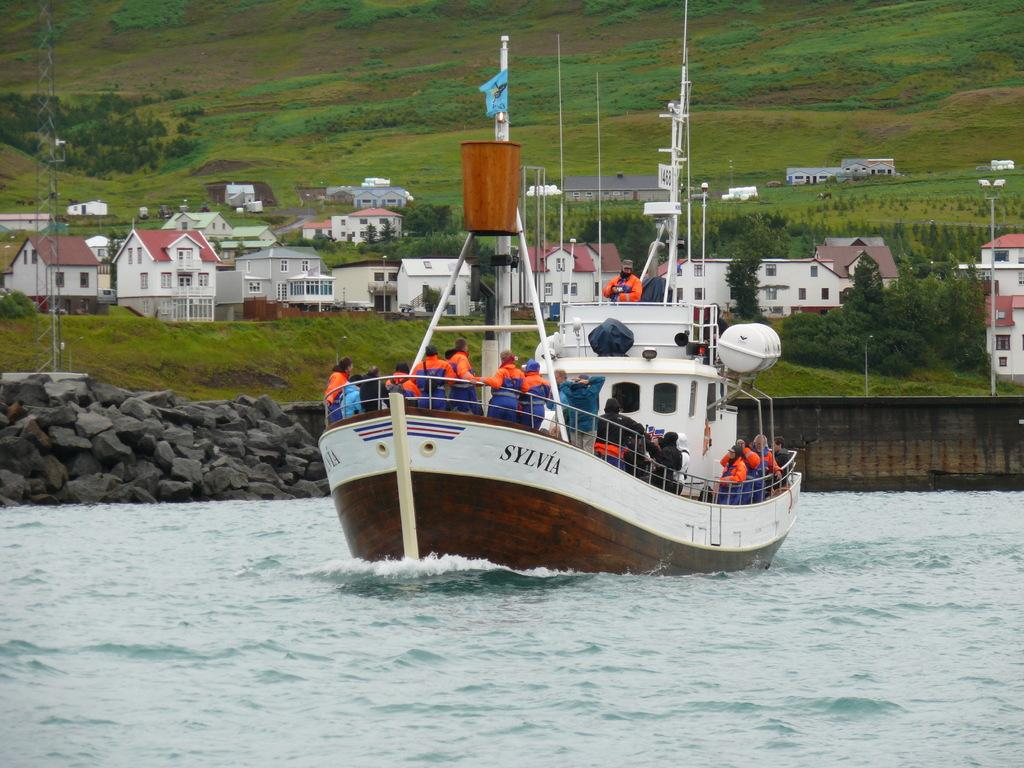How many people are in the image? There is a group of people in the image. Where are the people located in the image? The people are on a boat in the image. What is the boat on in the image? The boat is on the water in the image. What can be seen in the background of the image? There are rocks, trees, and houses in the background of the image. What type of produce is being harvested by the people in the image? There is no produce being harvested in the image; the people are on a boat. What is the basin used for in the image? There is no basin present in the image. 